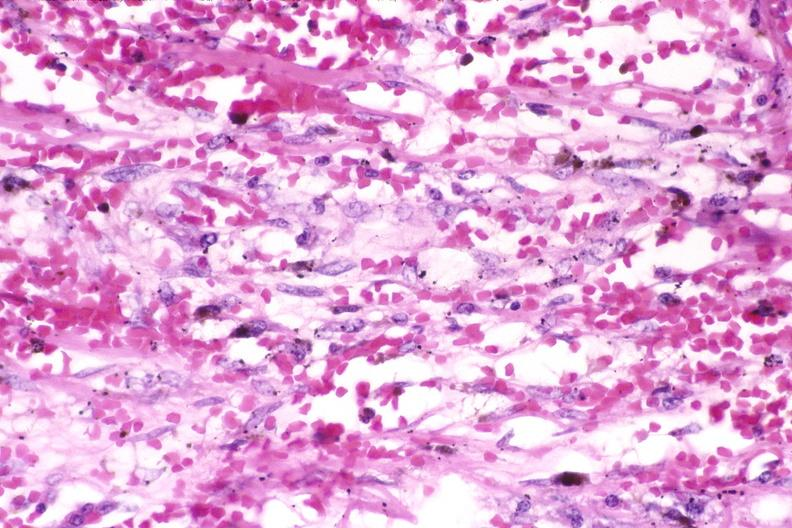does this image show skin, kaposis 's sarcoma?
Answer the question using a single word or phrase. Yes 